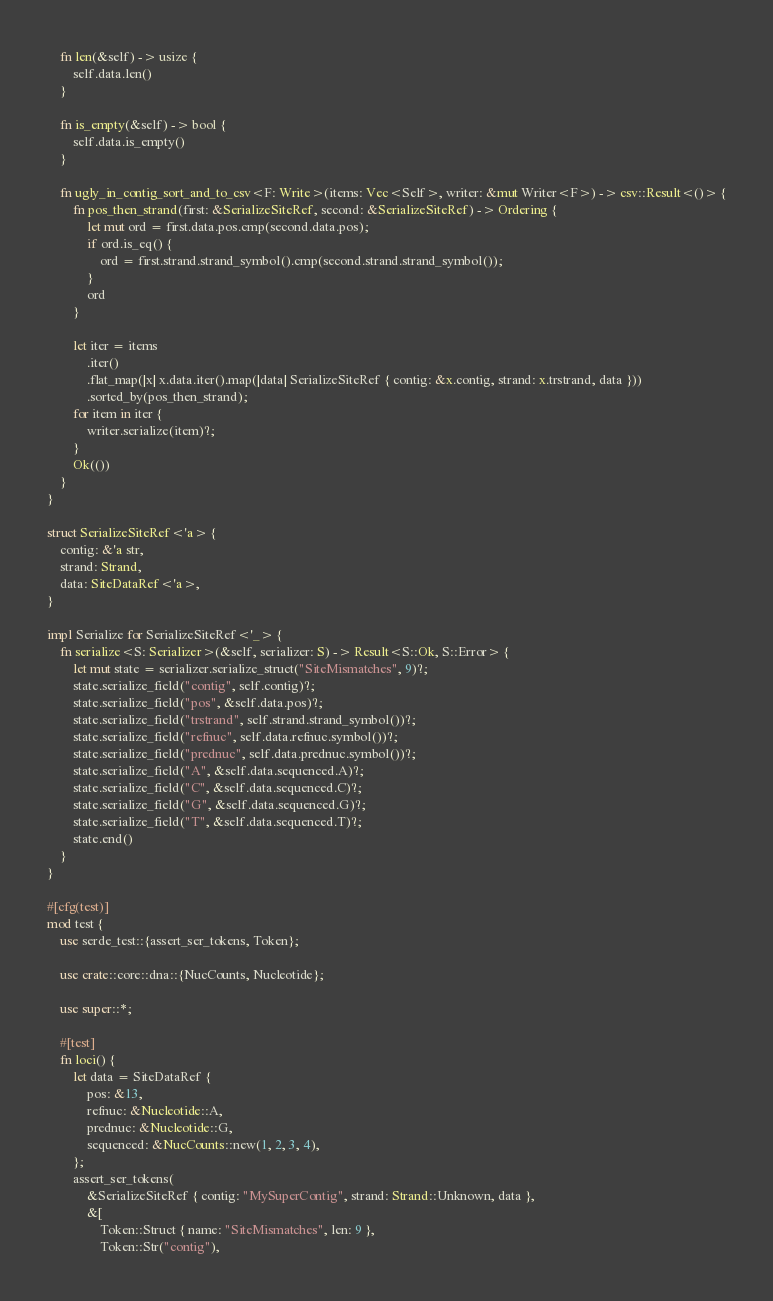Convert code to text. <code><loc_0><loc_0><loc_500><loc_500><_Rust_>
    fn len(&self) -> usize {
        self.data.len()
    }

    fn is_empty(&self) -> bool {
        self.data.is_empty()
    }

    fn ugly_in_contig_sort_and_to_csv<F: Write>(items: Vec<Self>, writer: &mut Writer<F>) -> csv::Result<()> {
        fn pos_then_strand(first: &SerializeSiteRef, second: &SerializeSiteRef) -> Ordering {
            let mut ord = first.data.pos.cmp(second.data.pos);
            if ord.is_eq() {
                ord = first.strand.strand_symbol().cmp(second.strand.strand_symbol());
            }
            ord
        }

        let iter = items
            .iter()
            .flat_map(|x| x.data.iter().map(|data| SerializeSiteRef { contig: &x.contig, strand: x.trstrand, data }))
            .sorted_by(pos_then_strand);
        for item in iter {
            writer.serialize(item)?;
        }
        Ok(())
    }
}

struct SerializeSiteRef<'a> {
    contig: &'a str,
    strand: Strand,
    data: SiteDataRef<'a>,
}

impl Serialize for SerializeSiteRef<'_> {
    fn serialize<S: Serializer>(&self, serializer: S) -> Result<S::Ok, S::Error> {
        let mut state = serializer.serialize_struct("SiteMismatches", 9)?;
        state.serialize_field("contig", self.contig)?;
        state.serialize_field("pos", &self.data.pos)?;
        state.serialize_field("trstrand", self.strand.strand_symbol())?;
        state.serialize_field("refnuc", self.data.refnuc.symbol())?;
        state.serialize_field("prednuc", self.data.prednuc.symbol())?;
        state.serialize_field("A", &self.data.sequenced.A)?;
        state.serialize_field("C", &self.data.sequenced.C)?;
        state.serialize_field("G", &self.data.sequenced.G)?;
        state.serialize_field("T", &self.data.sequenced.T)?;
        state.end()
    }
}

#[cfg(test)]
mod test {
    use serde_test::{assert_ser_tokens, Token};

    use crate::core::dna::{NucCounts, Nucleotide};

    use super::*;

    #[test]
    fn loci() {
        let data = SiteDataRef {
            pos: &13,
            refnuc: &Nucleotide::A,
            prednuc: &Nucleotide::G,
            sequenced: &NucCounts::new(1, 2, 3, 4),
        };
        assert_ser_tokens(
            &SerializeSiteRef { contig: "MySuperContig", strand: Strand::Unknown, data },
            &[
                Token::Struct { name: "SiteMismatches", len: 9 },
                Token::Str("contig"),</code> 